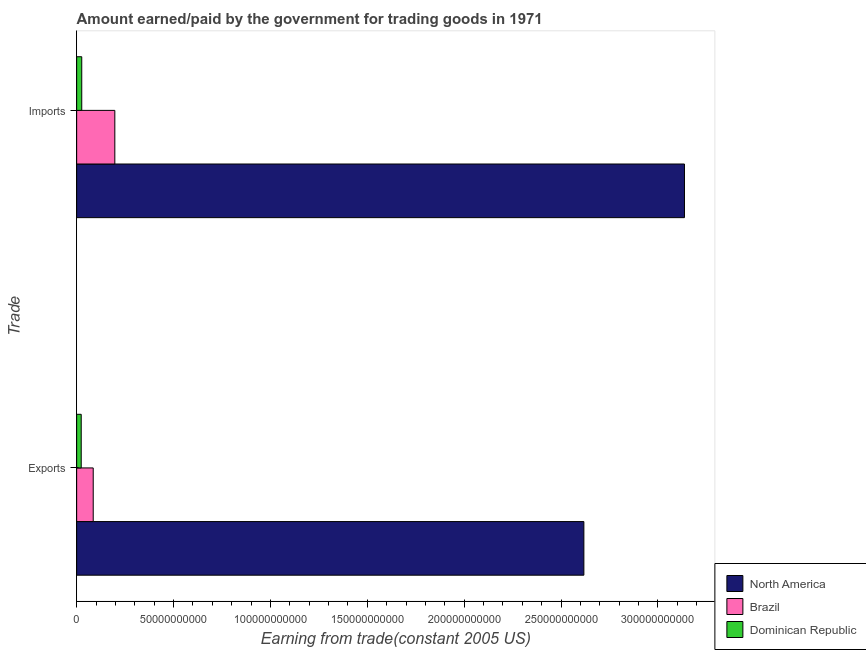How many bars are there on the 2nd tick from the top?
Ensure brevity in your answer.  3. What is the label of the 1st group of bars from the top?
Your answer should be compact. Imports. What is the amount paid for imports in Brazil?
Offer a terse response. 1.97e+1. Across all countries, what is the maximum amount earned from exports?
Keep it short and to the point. 2.62e+11. Across all countries, what is the minimum amount paid for imports?
Give a very brief answer. 2.63e+09. In which country was the amount earned from exports minimum?
Your answer should be compact. Dominican Republic. What is the total amount earned from exports in the graph?
Provide a succinct answer. 2.73e+11. What is the difference between the amount paid for imports in Brazil and that in North America?
Provide a short and direct response. -2.94e+11. What is the difference between the amount earned from exports in Brazil and the amount paid for imports in Dominican Republic?
Provide a succinct answer. 5.92e+09. What is the average amount paid for imports per country?
Keep it short and to the point. 1.12e+11. What is the difference between the amount paid for imports and amount earned from exports in Brazil?
Your answer should be very brief. 1.12e+1. In how many countries, is the amount paid for imports greater than 260000000000 US$?
Make the answer very short. 1. What is the ratio of the amount earned from exports in Dominican Republic to that in Brazil?
Give a very brief answer. 0.28. In how many countries, is the amount paid for imports greater than the average amount paid for imports taken over all countries?
Give a very brief answer. 1. How many bars are there?
Keep it short and to the point. 6. Are all the bars in the graph horizontal?
Ensure brevity in your answer.  Yes. How many countries are there in the graph?
Make the answer very short. 3. Are the values on the major ticks of X-axis written in scientific E-notation?
Provide a succinct answer. No. Where does the legend appear in the graph?
Provide a succinct answer. Bottom right. How are the legend labels stacked?
Your answer should be compact. Vertical. What is the title of the graph?
Provide a short and direct response. Amount earned/paid by the government for trading goods in 1971. Does "Liberia" appear as one of the legend labels in the graph?
Give a very brief answer. No. What is the label or title of the X-axis?
Your answer should be very brief. Earning from trade(constant 2005 US). What is the label or title of the Y-axis?
Offer a very short reply. Trade. What is the Earning from trade(constant 2005 US) of North America in Exports?
Offer a terse response. 2.62e+11. What is the Earning from trade(constant 2005 US) in Brazil in Exports?
Provide a short and direct response. 8.54e+09. What is the Earning from trade(constant 2005 US) of Dominican Republic in Exports?
Your response must be concise. 2.35e+09. What is the Earning from trade(constant 2005 US) of North America in Imports?
Offer a terse response. 3.14e+11. What is the Earning from trade(constant 2005 US) of Brazil in Imports?
Your answer should be very brief. 1.97e+1. What is the Earning from trade(constant 2005 US) of Dominican Republic in Imports?
Offer a terse response. 2.63e+09. Across all Trade, what is the maximum Earning from trade(constant 2005 US) in North America?
Offer a very short reply. 3.14e+11. Across all Trade, what is the maximum Earning from trade(constant 2005 US) in Brazil?
Your answer should be very brief. 1.97e+1. Across all Trade, what is the maximum Earning from trade(constant 2005 US) in Dominican Republic?
Your answer should be very brief. 2.63e+09. Across all Trade, what is the minimum Earning from trade(constant 2005 US) in North America?
Your response must be concise. 2.62e+11. Across all Trade, what is the minimum Earning from trade(constant 2005 US) of Brazil?
Your answer should be compact. 8.54e+09. Across all Trade, what is the minimum Earning from trade(constant 2005 US) of Dominican Republic?
Keep it short and to the point. 2.35e+09. What is the total Earning from trade(constant 2005 US) of North America in the graph?
Your answer should be compact. 5.75e+11. What is the total Earning from trade(constant 2005 US) in Brazil in the graph?
Provide a succinct answer. 2.82e+1. What is the total Earning from trade(constant 2005 US) of Dominican Republic in the graph?
Ensure brevity in your answer.  4.98e+09. What is the difference between the Earning from trade(constant 2005 US) of North America in Exports and that in Imports?
Your response must be concise. -5.19e+1. What is the difference between the Earning from trade(constant 2005 US) in Brazil in Exports and that in Imports?
Give a very brief answer. -1.12e+1. What is the difference between the Earning from trade(constant 2005 US) of Dominican Republic in Exports and that in Imports?
Your response must be concise. -2.72e+08. What is the difference between the Earning from trade(constant 2005 US) in North America in Exports and the Earning from trade(constant 2005 US) in Brazil in Imports?
Your answer should be very brief. 2.42e+11. What is the difference between the Earning from trade(constant 2005 US) of North America in Exports and the Earning from trade(constant 2005 US) of Dominican Republic in Imports?
Provide a succinct answer. 2.59e+11. What is the difference between the Earning from trade(constant 2005 US) of Brazil in Exports and the Earning from trade(constant 2005 US) of Dominican Republic in Imports?
Provide a short and direct response. 5.92e+09. What is the average Earning from trade(constant 2005 US) of North America per Trade?
Ensure brevity in your answer.  2.88e+11. What is the average Earning from trade(constant 2005 US) of Brazil per Trade?
Your answer should be very brief. 1.41e+1. What is the average Earning from trade(constant 2005 US) in Dominican Republic per Trade?
Keep it short and to the point. 2.49e+09. What is the difference between the Earning from trade(constant 2005 US) in North America and Earning from trade(constant 2005 US) in Brazil in Exports?
Your answer should be very brief. 2.53e+11. What is the difference between the Earning from trade(constant 2005 US) of North America and Earning from trade(constant 2005 US) of Dominican Republic in Exports?
Give a very brief answer. 2.59e+11. What is the difference between the Earning from trade(constant 2005 US) in Brazil and Earning from trade(constant 2005 US) in Dominican Republic in Exports?
Offer a terse response. 6.19e+09. What is the difference between the Earning from trade(constant 2005 US) of North America and Earning from trade(constant 2005 US) of Brazil in Imports?
Your answer should be compact. 2.94e+11. What is the difference between the Earning from trade(constant 2005 US) of North America and Earning from trade(constant 2005 US) of Dominican Republic in Imports?
Give a very brief answer. 3.11e+11. What is the difference between the Earning from trade(constant 2005 US) in Brazil and Earning from trade(constant 2005 US) in Dominican Republic in Imports?
Make the answer very short. 1.71e+1. What is the ratio of the Earning from trade(constant 2005 US) in North America in Exports to that in Imports?
Ensure brevity in your answer.  0.83. What is the ratio of the Earning from trade(constant 2005 US) of Brazil in Exports to that in Imports?
Your answer should be very brief. 0.43. What is the ratio of the Earning from trade(constant 2005 US) of Dominican Republic in Exports to that in Imports?
Your response must be concise. 0.9. What is the difference between the highest and the second highest Earning from trade(constant 2005 US) in North America?
Your answer should be very brief. 5.19e+1. What is the difference between the highest and the second highest Earning from trade(constant 2005 US) in Brazil?
Ensure brevity in your answer.  1.12e+1. What is the difference between the highest and the second highest Earning from trade(constant 2005 US) in Dominican Republic?
Ensure brevity in your answer.  2.72e+08. What is the difference between the highest and the lowest Earning from trade(constant 2005 US) in North America?
Make the answer very short. 5.19e+1. What is the difference between the highest and the lowest Earning from trade(constant 2005 US) of Brazil?
Your answer should be compact. 1.12e+1. What is the difference between the highest and the lowest Earning from trade(constant 2005 US) of Dominican Republic?
Your answer should be compact. 2.72e+08. 